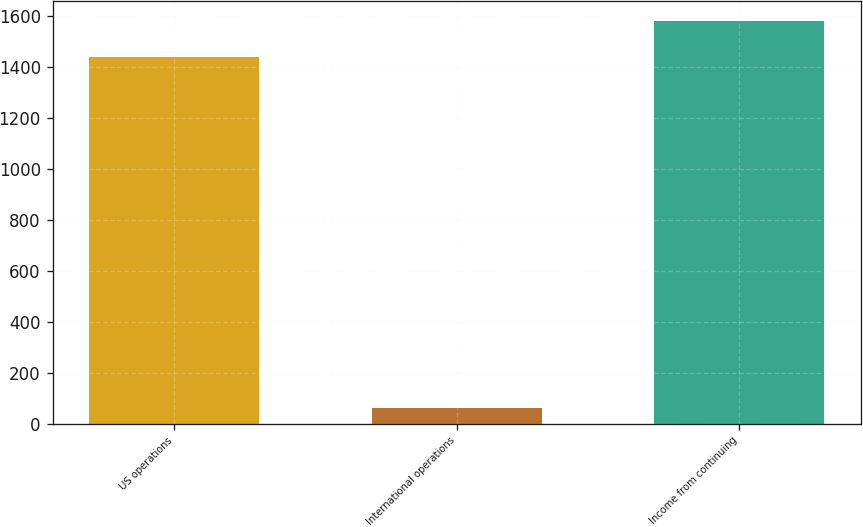Convert chart. <chart><loc_0><loc_0><loc_500><loc_500><bar_chart><fcel>US operations<fcel>International operations<fcel>Income from continuing<nl><fcel>1436<fcel>62<fcel>1579.6<nl></chart> 